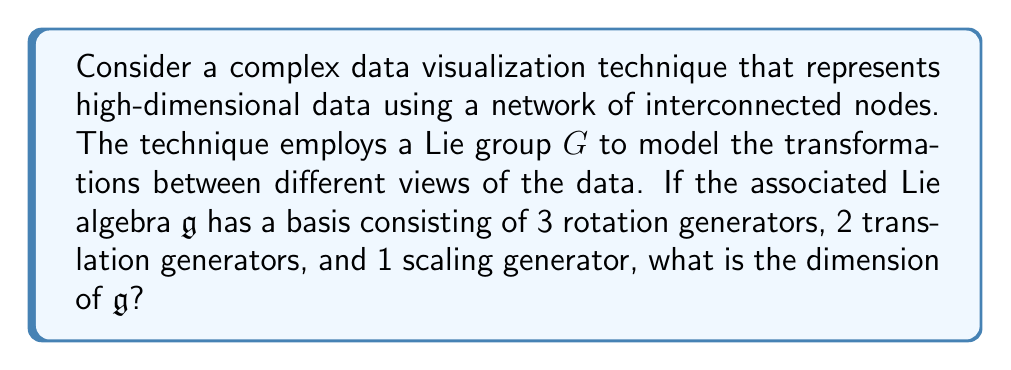What is the answer to this math problem? To solve this problem, we need to understand the relationship between Lie groups and Lie algebras, and how the dimension of a Lie algebra is determined.

1. Lie algebras and Lie groups:
   - A Lie algebra $\mathfrak{g}$ is the tangent space at the identity element of a Lie group $G$.
   - The dimension of a Lie algebra is equal to the dimension of its corresponding Lie group.

2. Basis of a Lie algebra:
   - The dimension of a Lie algebra is equal to the number of linearly independent elements in its basis.
   - Each generator in the basis corresponds to a fundamental transformation or operation.

3. Counting the generators:
   - Rotation generators: 3
   - Translation generators: 2
   - Scaling generator: 1

4. Calculating the dimension:
   - The total number of generators in the basis is the sum of all types of generators.
   - Dimension = Rotations + Translations + Scaling
   - Dimension = 3 + 2 + 1 = 6

Therefore, the Lie algebra $\mathfrak{g}$ has a dimension of 6.

This result is particularly relevant to data visualization as it quantifies the degrees of freedom available in the transformation space. A 6-dimensional Lie algebra allows for a rich set of operations to be applied to the visualized data, enabling complex manipulations and perspectives that can enhance the understanding of high-dimensional datasets.
Answer: The dimension of the Lie algebra $\mathfrak{g}$ is 6. 